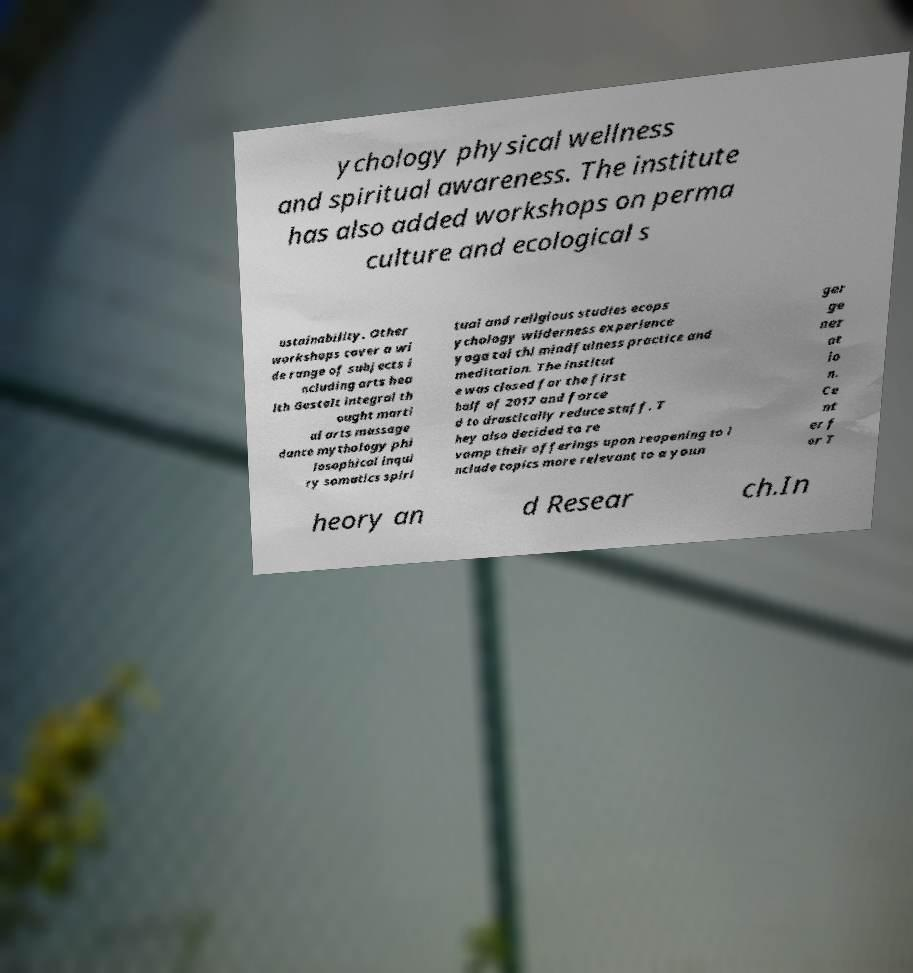Could you assist in decoding the text presented in this image and type it out clearly? ychology physical wellness and spiritual awareness. The institute has also added workshops on perma culture and ecological s ustainability. Other workshops cover a wi de range of subjects i ncluding arts hea lth Gestalt integral th ought marti al arts massage dance mythology phi losophical inqui ry somatics spiri tual and religious studies ecops ychology wilderness experience yoga tai chi mindfulness practice and meditation. The institut e was closed for the first half of 2017 and force d to drastically reduce staff. T hey also decided to re vamp their offerings upon reopening to i nclude topics more relevant to a youn ger ge ner at io n. Ce nt er f or T heory an d Resear ch.In 